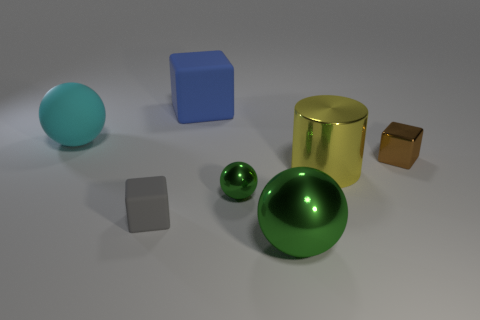Subtract all tiny brown cubes. How many cubes are left? 2 Subtract all gray cubes. How many cubes are left? 2 Add 1 tiny shiny cubes. How many objects exist? 8 Subtract 2 balls. How many balls are left? 1 Subtract all yellow cylinders. How many green balls are left? 2 Subtract all balls. How many objects are left? 4 Add 2 tiny things. How many tiny things are left? 5 Add 4 blue metallic balls. How many blue metallic balls exist? 4 Subtract 0 brown cylinders. How many objects are left? 7 Subtract all purple cylinders. Subtract all cyan cubes. How many cylinders are left? 1 